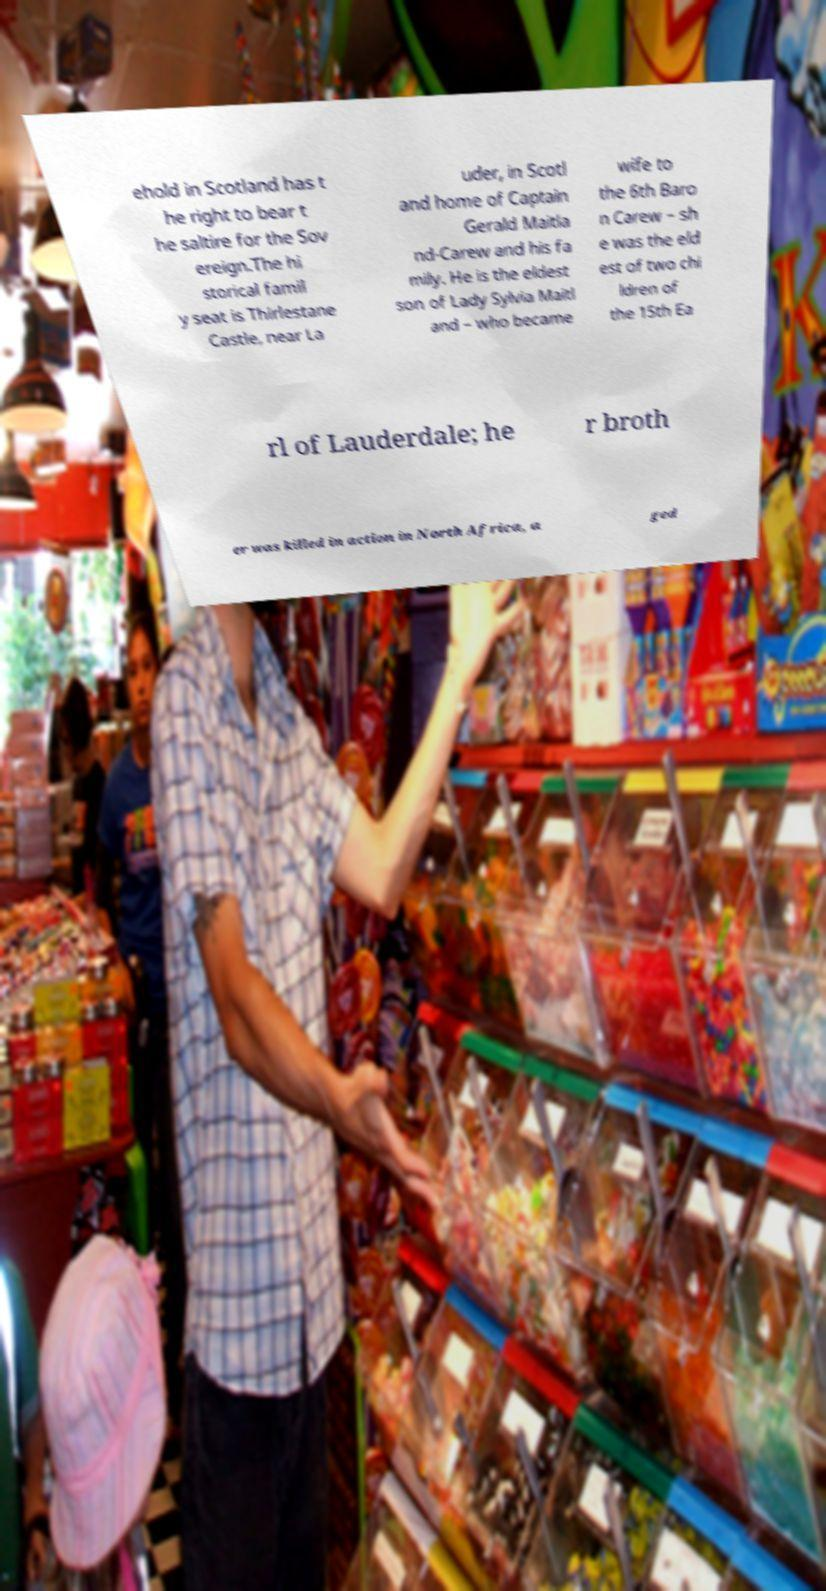There's text embedded in this image that I need extracted. Can you transcribe it verbatim? ehold in Scotland has t he right to bear t he saltire for the Sov ereign.The hi storical famil y seat is Thirlestane Castle, near La uder, in Scotl and home of Captain Gerald Maitla nd-Carew and his fa mily. He is the eldest son of Lady Sylvia Maitl and – who became wife to the 6th Baro n Carew – sh e was the eld est of two chi ldren of the 15th Ea rl of Lauderdale; he r broth er was killed in action in North Africa, a ged 